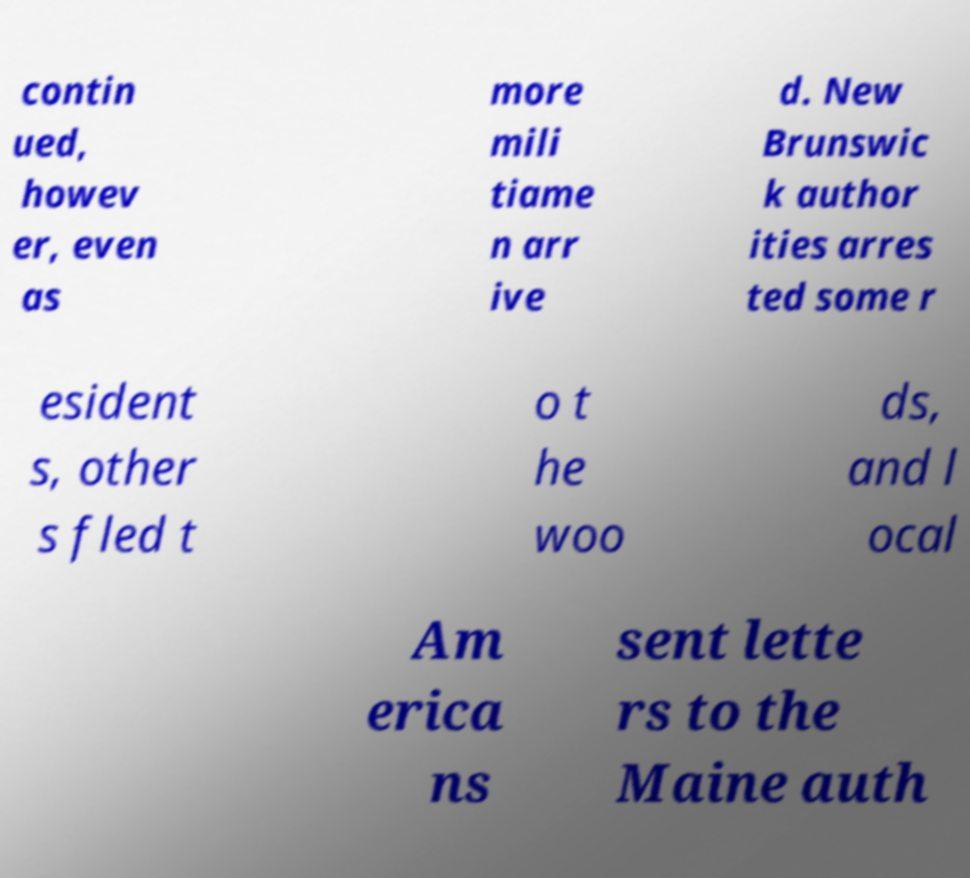What messages or text are displayed in this image? I need them in a readable, typed format. contin ued, howev er, even as more mili tiame n arr ive d. New Brunswic k author ities arres ted some r esident s, other s fled t o t he woo ds, and l ocal Am erica ns sent lette rs to the Maine auth 